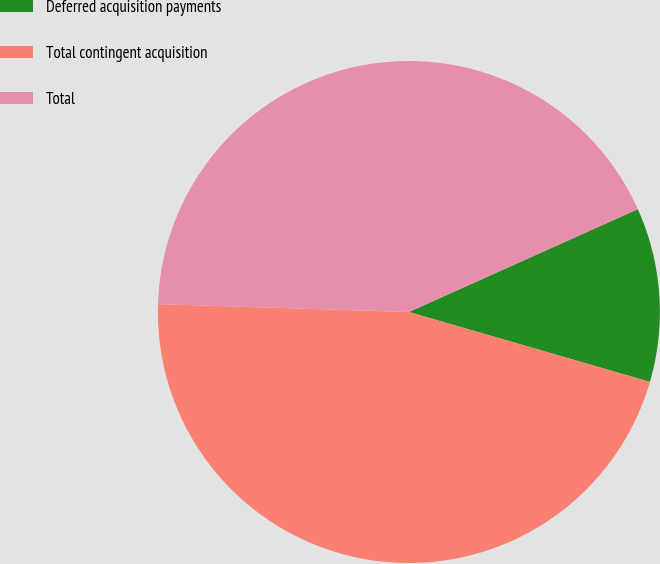Convert chart to OTSL. <chart><loc_0><loc_0><loc_500><loc_500><pie_chart><fcel>Deferred acquisition payments<fcel>Total contingent acquisition<fcel>Total<nl><fcel>11.21%<fcel>46.0%<fcel>42.78%<nl></chart> 